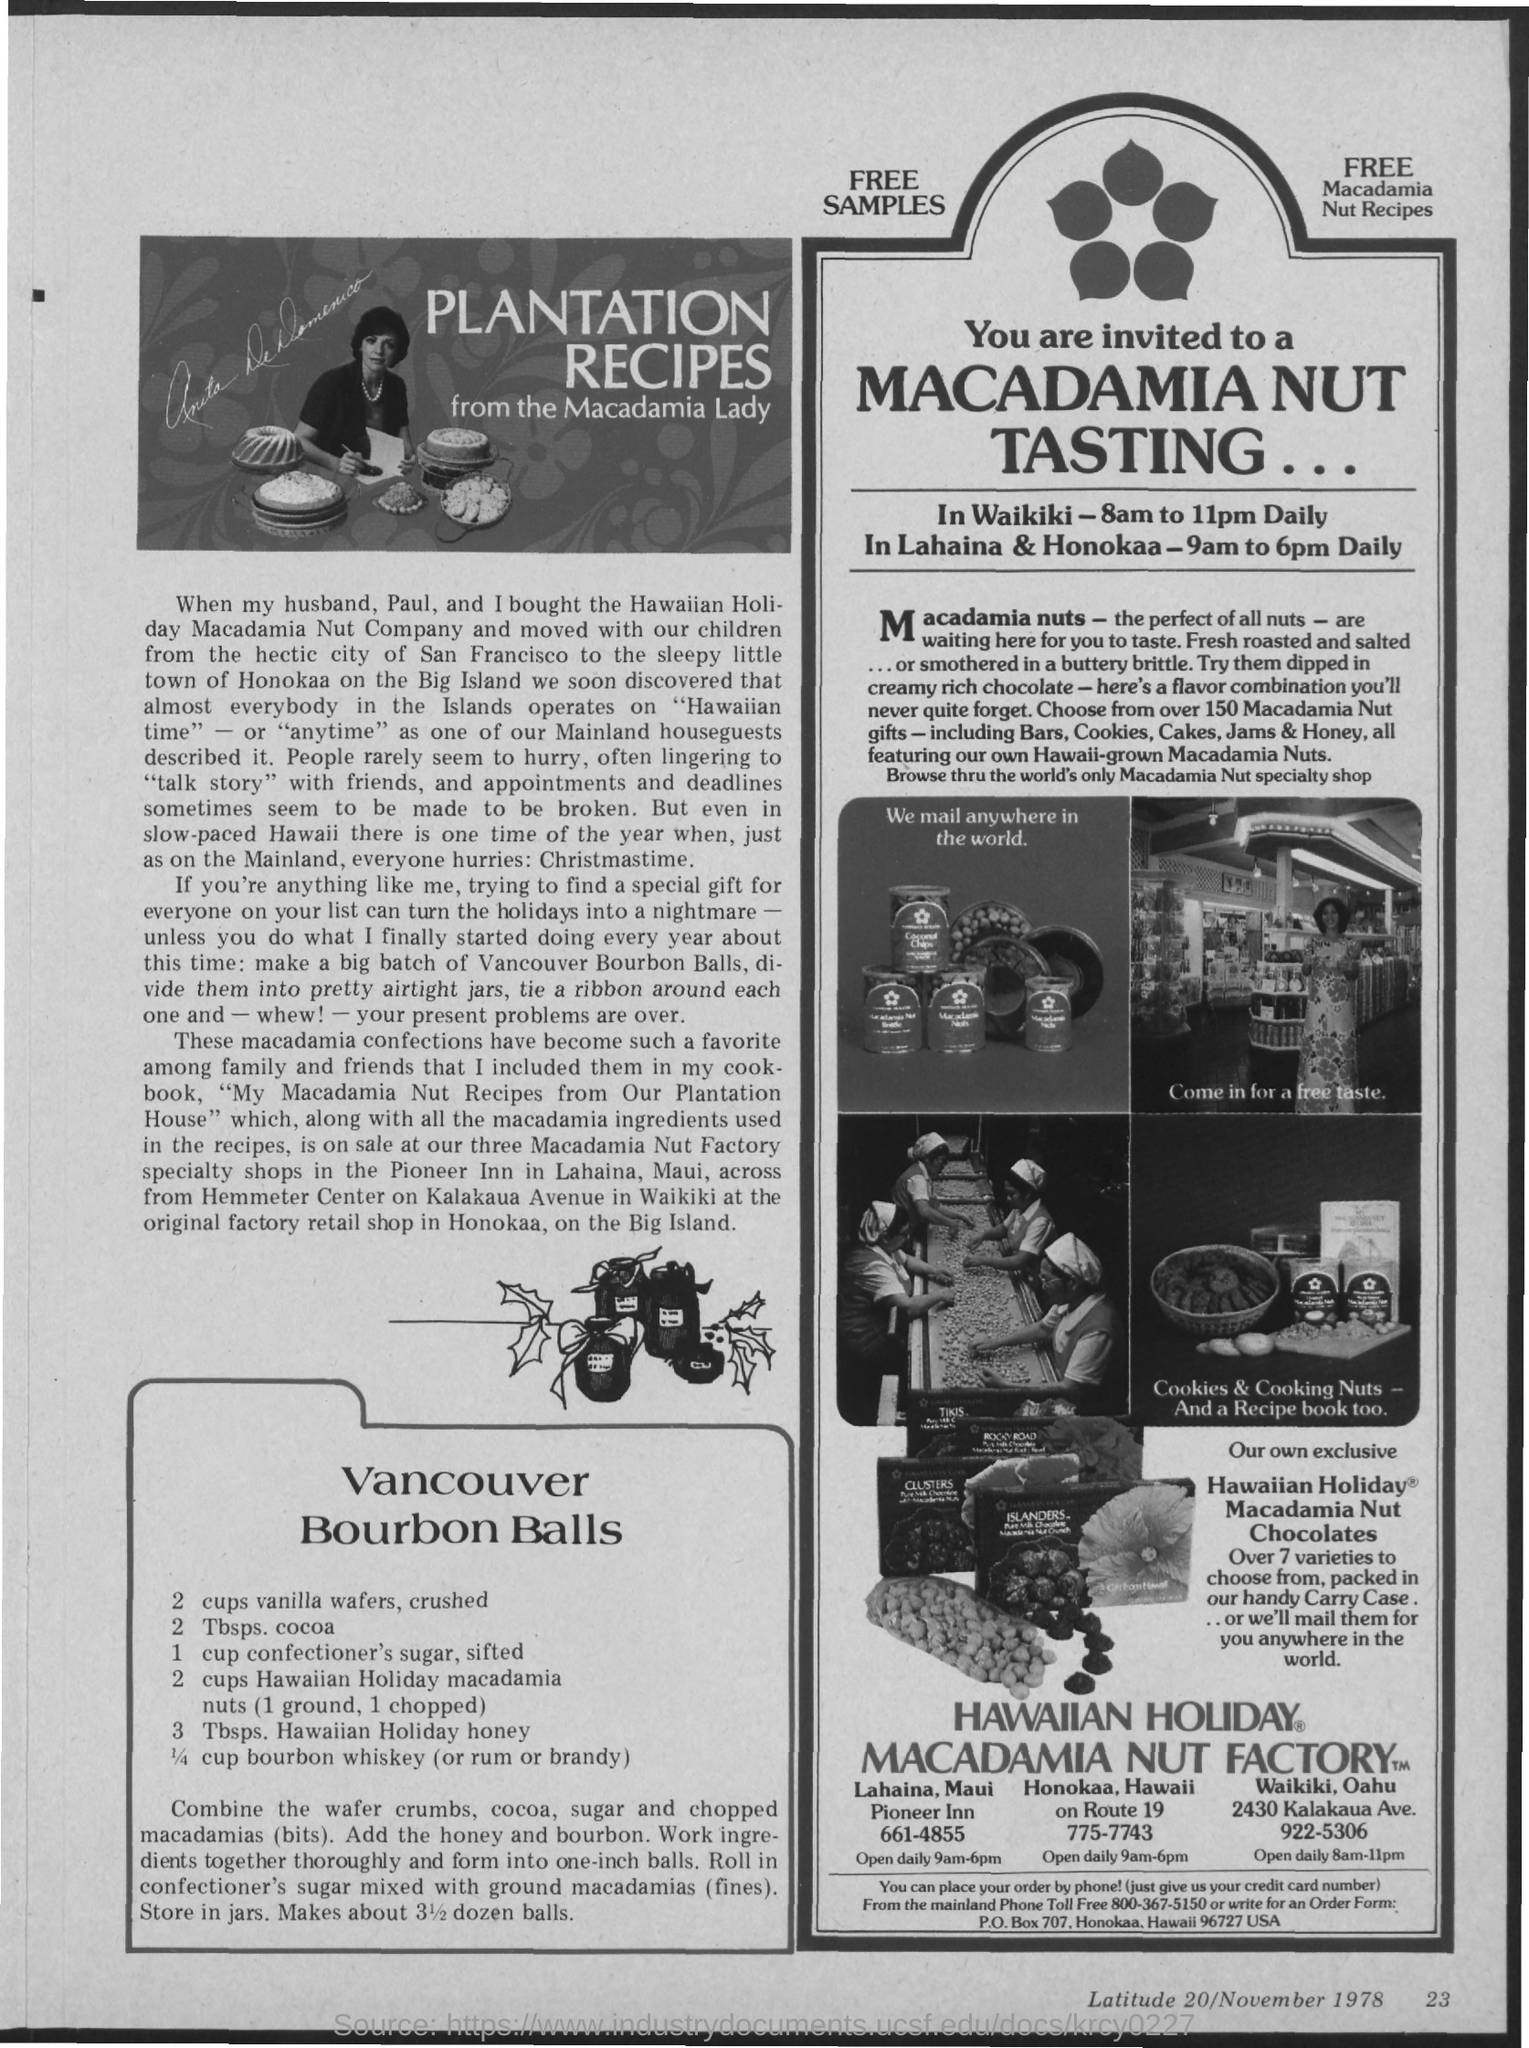The plantation recipes are by whom?
Give a very brief answer. Macadamia Lady. 